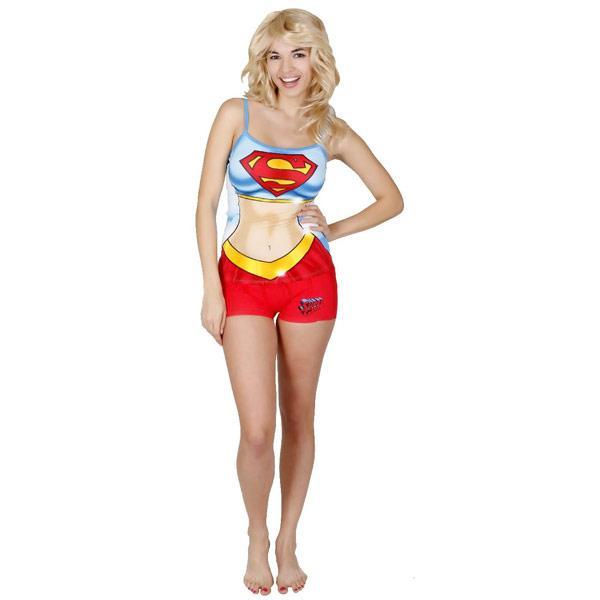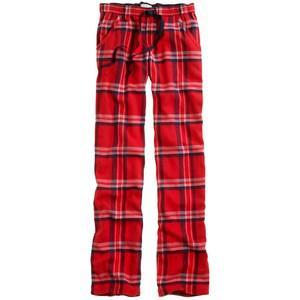The first image is the image on the left, the second image is the image on the right. Examine the images to the left and right. Is the description "There is a woman with her hand on her hips and her shoulder sticking out." accurate? Answer yes or no. Yes. 